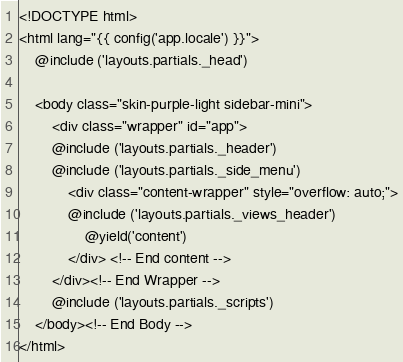<code> <loc_0><loc_0><loc_500><loc_500><_PHP_><!DOCTYPE html>
<html lang="{{ config('app.locale') }}">
    @include ('layouts.partials._head')

    <body class="skin-purple-light sidebar-mini">
        <div class="wrapper" id="app">
        @include ('layouts.partials._header')
        @include ('layouts.partials._side_menu')
            <div class="content-wrapper" style="overflow: auto;">
            @include ('layouts.partials._views_header')
                @yield('content')
            </div> <!-- End content -->
        </div><!-- End Wrapper -->
        @include ('layouts.partials._scripts')
    </body><!-- End Body -->
</html></code> 